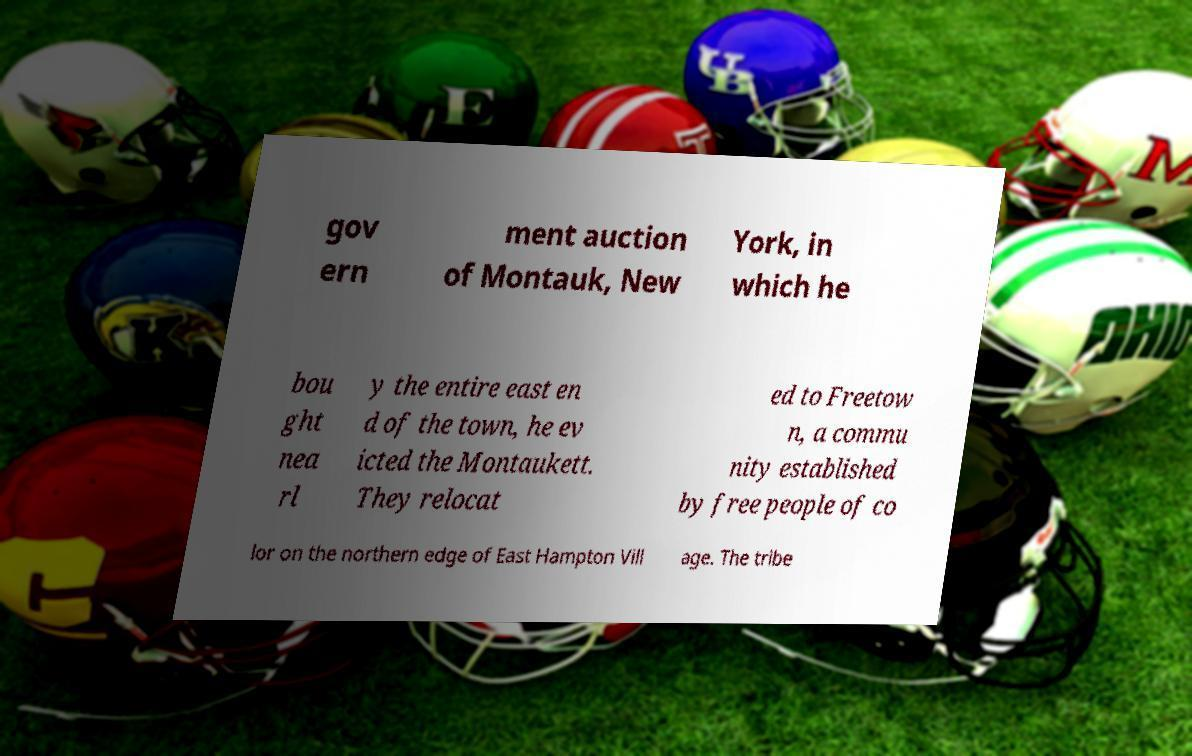Please identify and transcribe the text found in this image. gov ern ment auction of Montauk, New York, in which he bou ght nea rl y the entire east en d of the town, he ev icted the Montaukett. They relocat ed to Freetow n, a commu nity established by free people of co lor on the northern edge of East Hampton Vill age. The tribe 